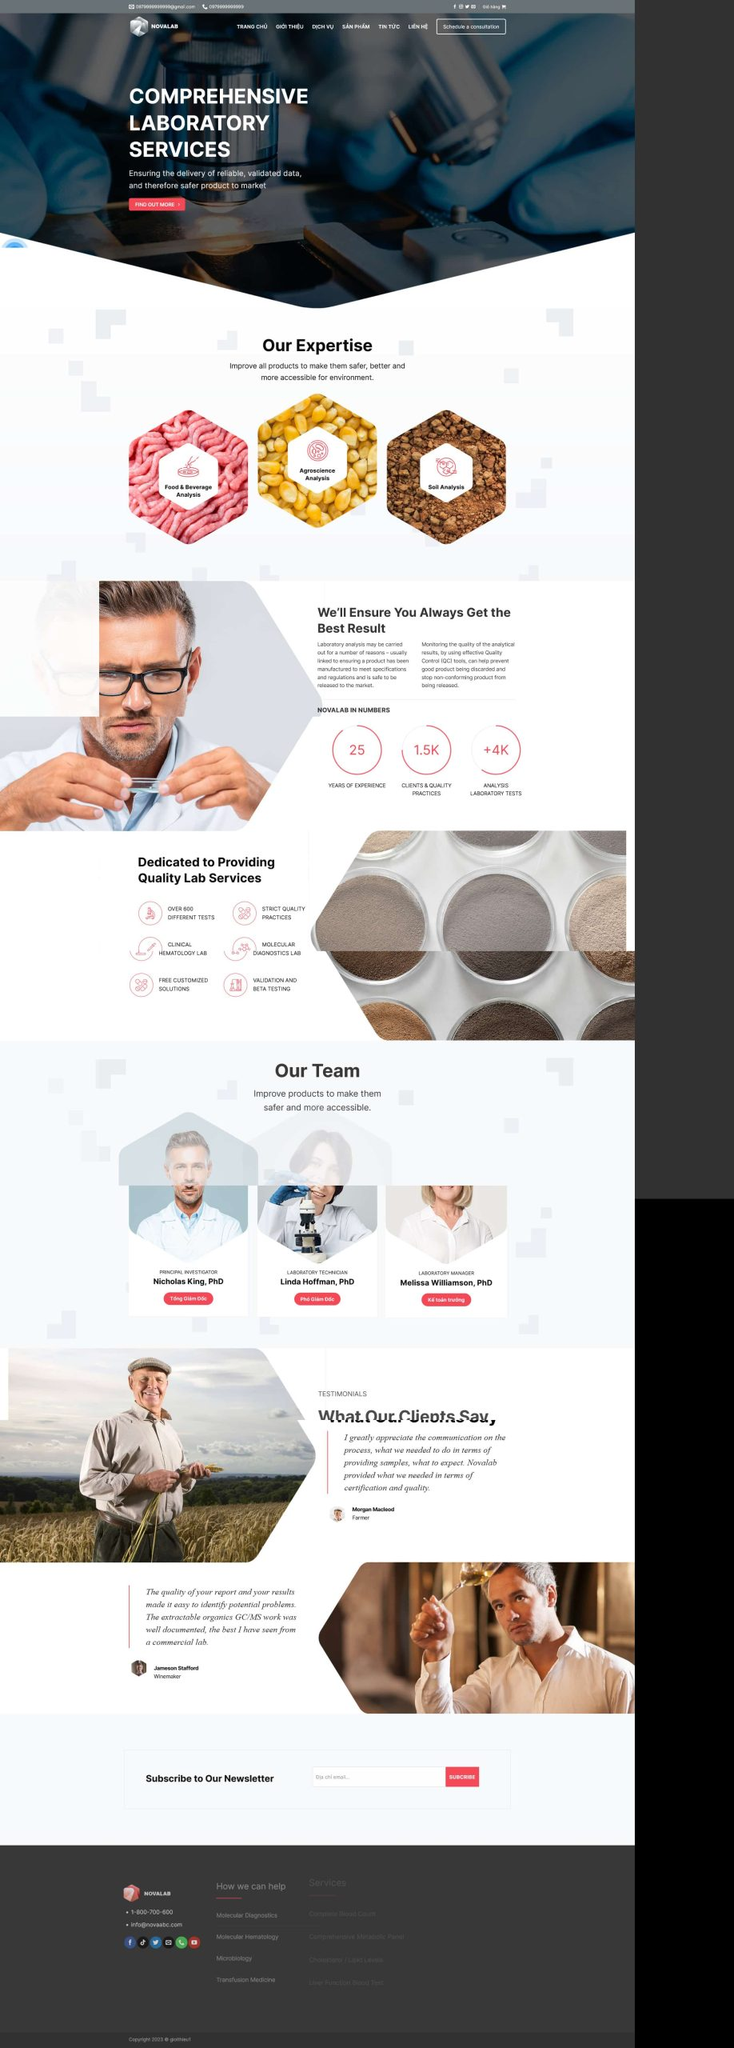Liệt kê 5 ngành nghề, lĩnh vực phù hợp với website này, phân cách các màu sắc bằng dấu phẩy. Chỉ trả về kết quả, phân cách bằng dấy phẩy
 Công nghệ sinh học, Thực phẩm và đồ uống, Nông nghiệp, Phân tích đất, Phân tích môi trường 